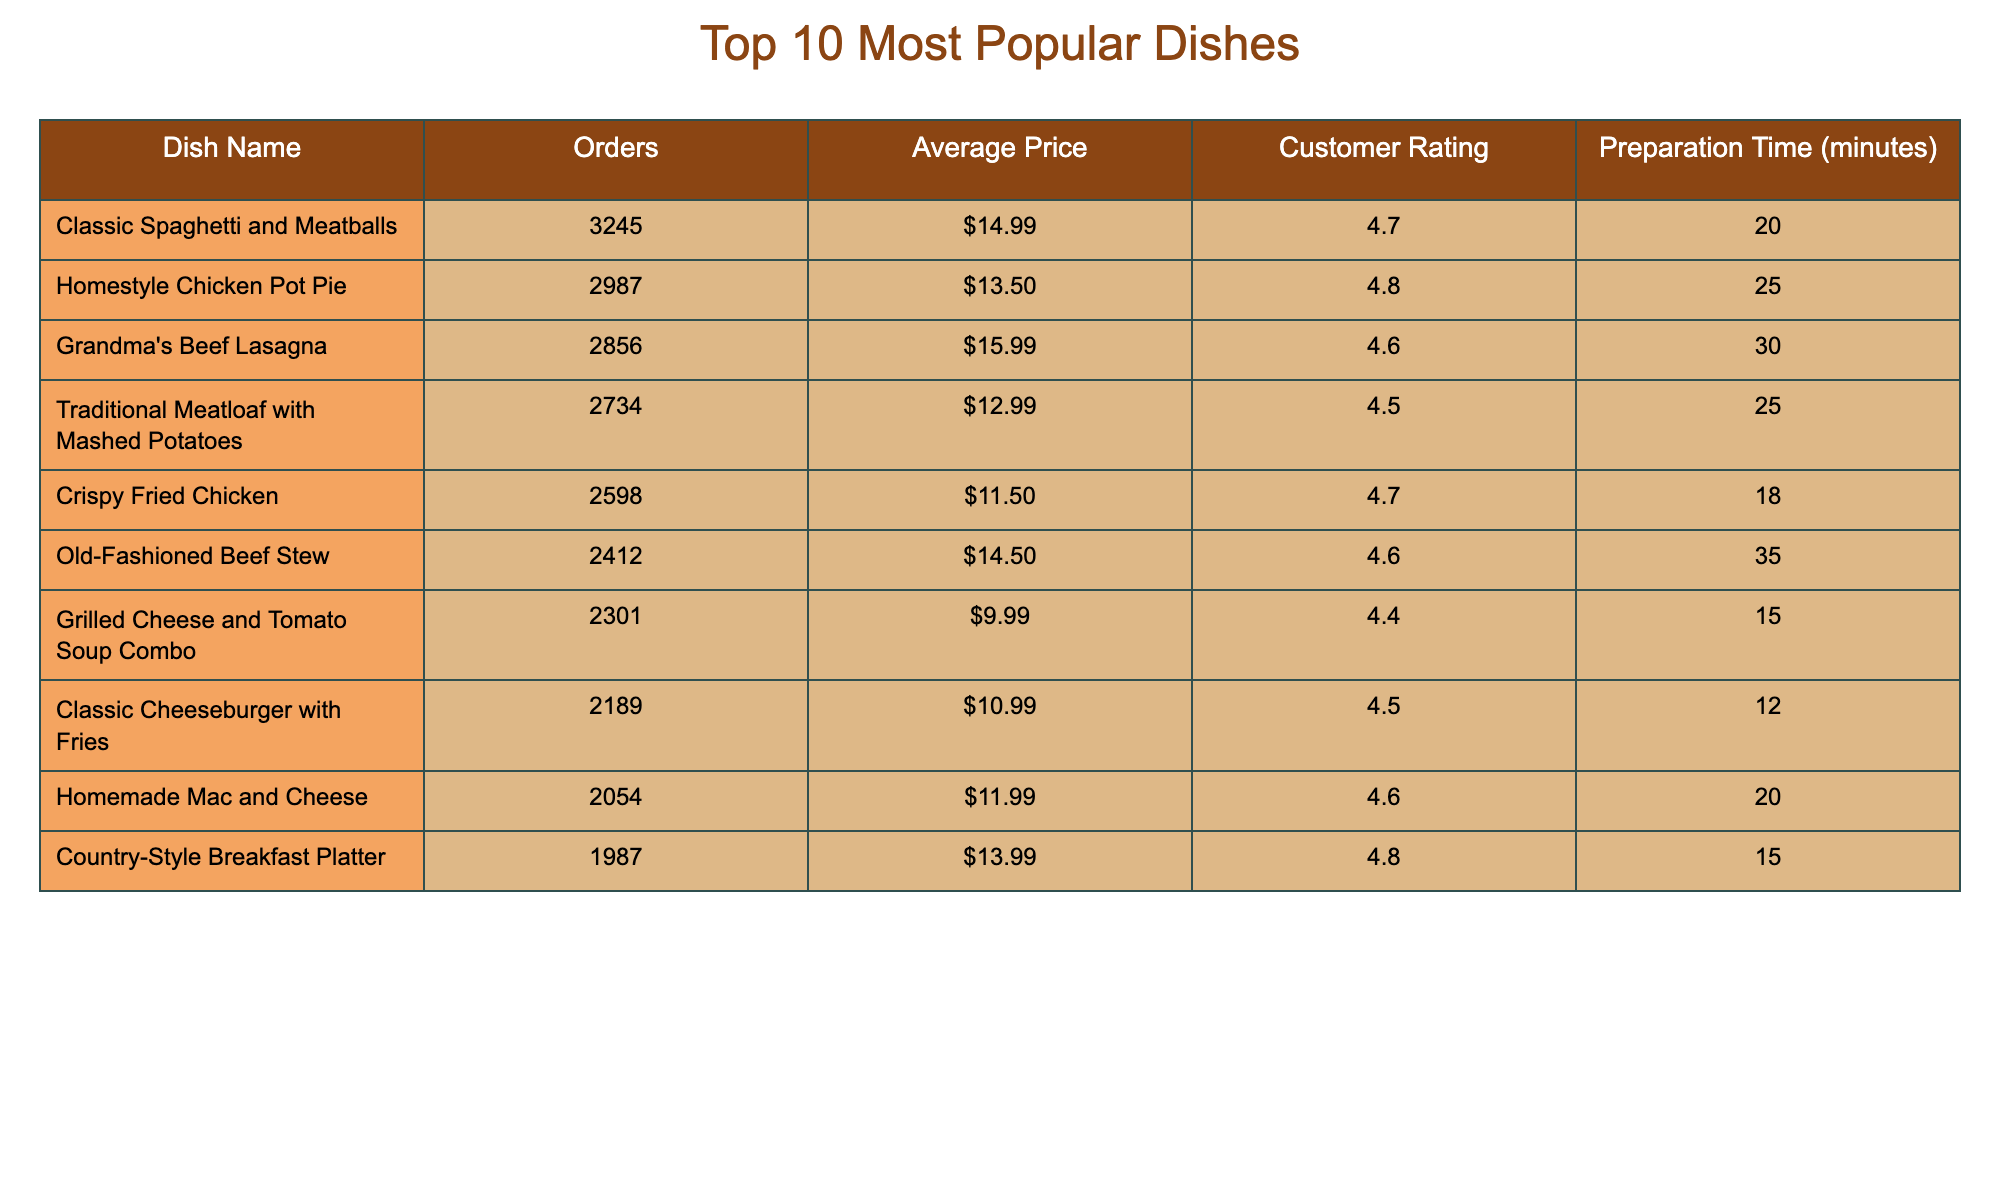What dish had the highest number of orders? The table shows the number of orders for each dish, and "Classic Spaghetti and Meatballs" has the highest number at 3245 orders.
Answer: Classic Spaghetti and Meatballs What is the average price of "Homestyle Chicken Pot Pie"? The "Average Price" column indicates that "Homestyle Chicken Pot Pie" is priced at $13.50.
Answer: $13.50 Which dish has the lowest customer rating? By checking the "Customer Rating" column, "Classic Cheeseburger with Fries" has the lowest rating at 4.5.
Answer: Classic Cheeseburger with Fries What is the total number of orders for the top three dishes? To find this, add the orders for the top three dishes: 3245 + 2987 + 2856 = 9088.
Answer: 9088 Are any dishes ordered more than 3000 times? Checking the "Orders" column reveals that only "Classic Spaghetti and Meatballs" exceeds 3000 orders.
Answer: Yes What is the average preparation time for the dishes? Add up the preparation times (20 + 25 + 30 + 25 + 18 + 35 + 15 + 12 + 20 + 15 =  225) and divide by 10 (the number of dishes): 225 / 10 = 22.5 minutes.
Answer: 22.5 minutes Which dish has the longest preparation time, and how long is it? The "Preparation Time" column shows that "Old-Fashioned Beef Stew" has the longest preparation time of 35 minutes.
Answer: Old-Fashioned Beef Stew, 35 minutes Is the average price greater than $12 for all dishes? Checking the prices, the average price is calculated as (14.99 + 13.50 + 15.99 + 12.99 + 11.50 + 14.50 + 9.99 + 10.99 + 11.99 + 13.99) / 10 = 12.79, which is greater than $12.
Answer: Yes What is the difference between the highest and lowest average prices? The highest average price is $15.99 for "Grandma's Beef Lasagna," and the lowest is $9.99 for "Grilled Cheese and Tomato Soup Combo." The difference is $15.99 - $9.99 = $6.00.
Answer: $6.00 Which dish has a customer rating of exactly 4.8? The table shows that both "Homestyle Chicken Pot Pie" and "Country-Style Breakfast Platter" have a customer rating of 4.8.
Answer: Homestyle Chicken Pot Pie, Country-Style Breakfast Platter 